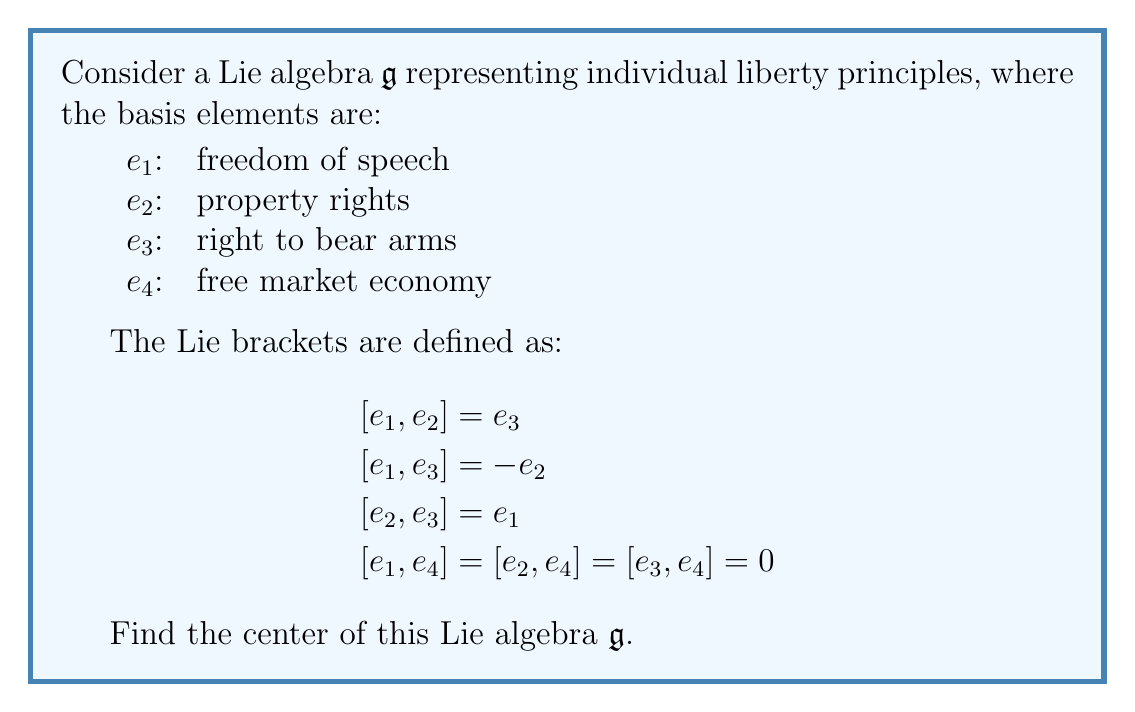Give your solution to this math problem. To find the center of the Lie algebra $\mathfrak{g}$, we need to determine the set of elements that commute with all other elements in $\mathfrak{g}$. Let's approach this step-by-step:

1) First, let's consider a general element $x = a_1e_1 + a_2e_2 + a_3e_3 + a_4e_4$ in $\mathfrak{g}$.

2) For $x$ to be in the center, it must satisfy $[x, e_i] = 0$ for all $i = 1, 2, 3, 4$.

3) Let's calculate these brackets:

   $[x, e_1] = [a_1e_1 + a_2e_2 + a_3e_3 + a_4e_4, e_1]$
             $= a_2[e_2, e_1] + a_3[e_3, e_1]$
             $= -a_2e_3 + a_3e_2$

   $[x, e_2] = [a_1e_1 + a_2e_2 + a_3e_3 + a_4e_4, e_2]$
             $= a_1[e_1, e_2] + a_3[e_3, e_2]$
             $= a_1e_3 - a_3e_1$

   $[x, e_3] = [a_1e_1 + a_2e_2 + a_3e_3 + a_4e_4, e_3]$
             $= a_1[e_1, e_3] + a_2[e_2, e_3]$
             $= -a_1e_2 + a_2e_1$

   $[x, e_4] = [a_1e_1 + a_2e_2 + a_3e_3 + a_4e_4, e_4] = 0$

4) For $x$ to be in the center, all these brackets must be zero. This gives us the following system of equations:

   $-a_2e_3 + a_3e_2 = 0$
   $a_1e_3 - a_3e_1 = 0$
   $-a_1e_2 + a_2e_1 = 0$

5) For these equations to hold, we must have:

   $a_1 = a_2 = a_3 = 0$

6) There is no constraint on $a_4$, which means any multiple of $e_4$ will be in the center.

Therefore, the center of $\mathfrak{g}$ consists of all elements of the form $a_4e_4$, where $a_4$ is any scalar.
Answer: The center of the Lie algebra $\mathfrak{g}$ is $\{a_4e_4 | a_4 \in \mathbb{R}\}$, which is isomorphic to $\mathbb{R}$. 